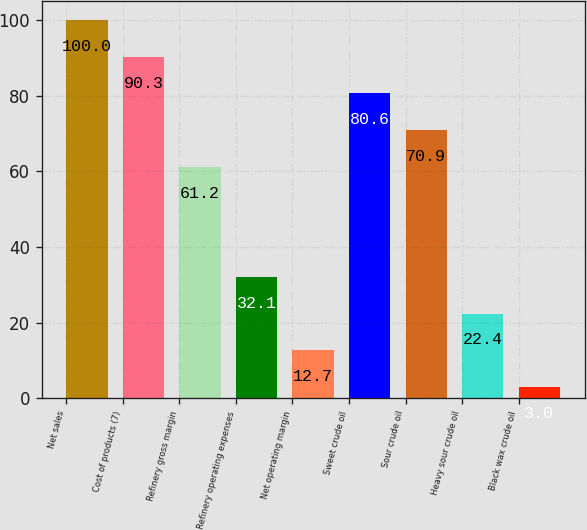Convert chart to OTSL. <chart><loc_0><loc_0><loc_500><loc_500><bar_chart><fcel>Net sales<fcel>Cost of products (7)<fcel>Refinery gross margin<fcel>Refinery operating expenses<fcel>Net operating margin<fcel>Sweet crude oil<fcel>Sour crude oil<fcel>Heavy sour crude oil<fcel>Black wax crude oil<nl><fcel>100<fcel>90.3<fcel>61.2<fcel>32.1<fcel>12.7<fcel>80.6<fcel>70.9<fcel>22.4<fcel>3<nl></chart> 